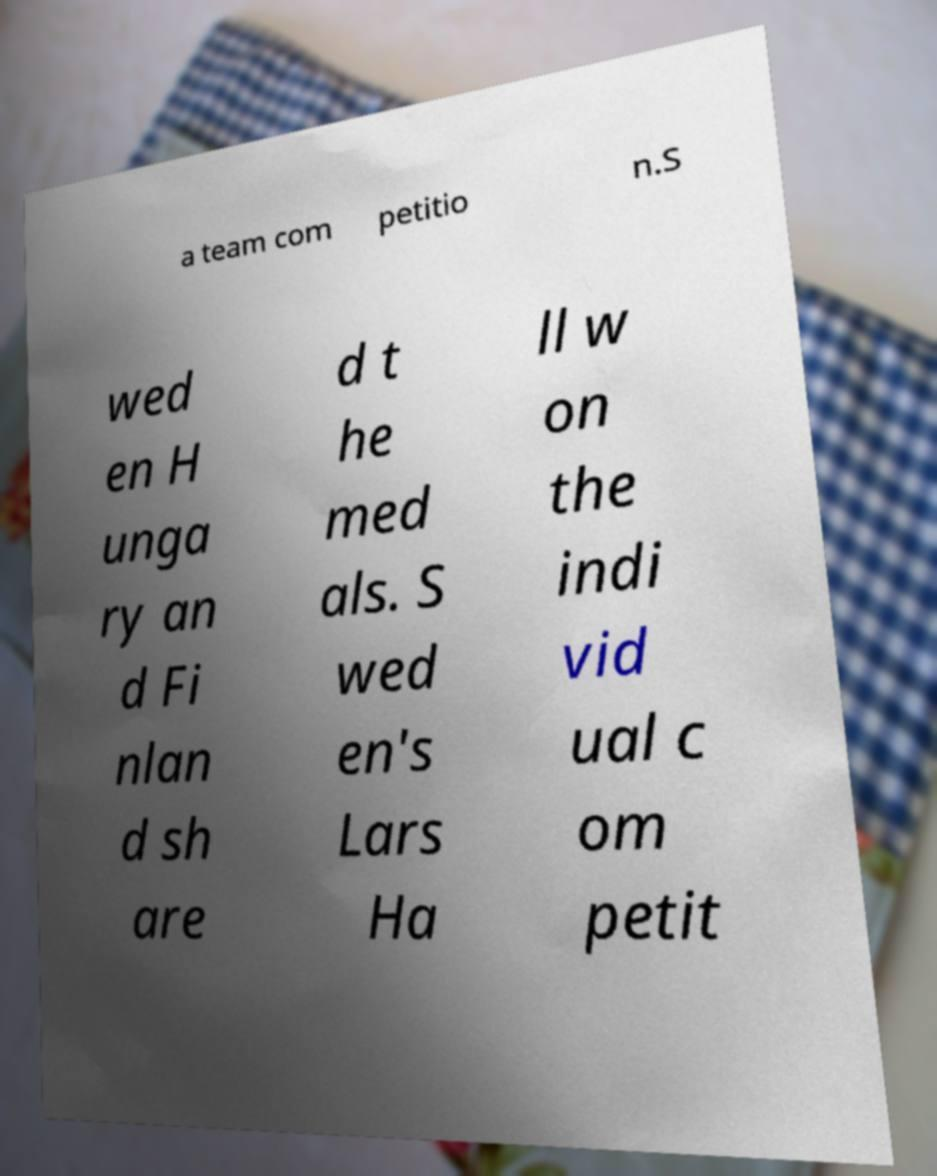Could you assist in decoding the text presented in this image and type it out clearly? a team com petitio n.S wed en H unga ry an d Fi nlan d sh are d t he med als. S wed en's Lars Ha ll w on the indi vid ual c om petit 